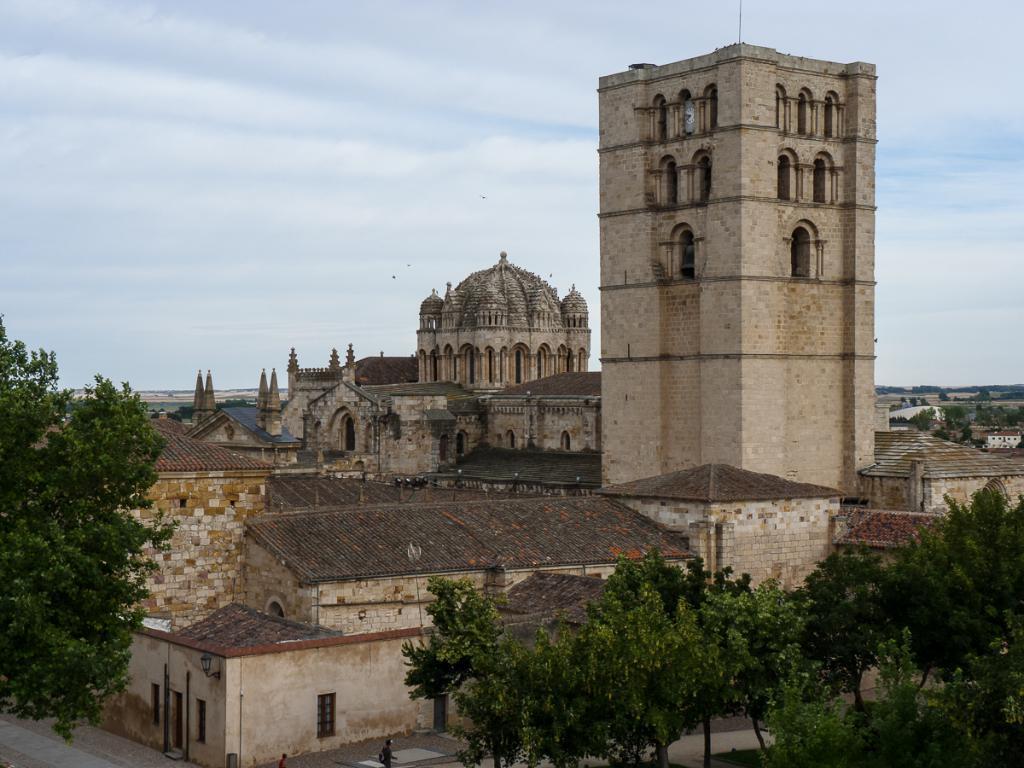Can you describe this image briefly? In this image we can see buildings, trees, road, sky and clouds. 